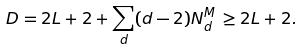Convert formula to latex. <formula><loc_0><loc_0><loc_500><loc_500>D = 2 L + 2 + \sum _ { d } ( d - 2 ) N _ { d } ^ { M } \, \geq 2 L + 2 .</formula> 